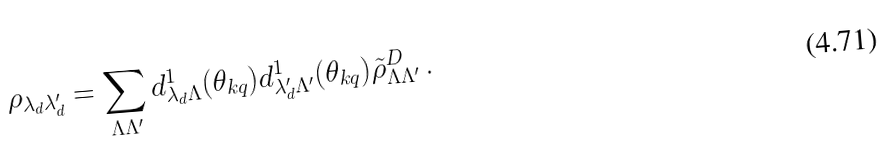<formula> <loc_0><loc_0><loc_500><loc_500>\rho _ { \lambda _ { d } \lambda ^ { \prime } _ { d } } = \sum _ { \Lambda \Lambda ^ { \prime } } d ^ { 1 } _ { \lambda _ { d } \Lambda } ( \theta _ { k q } ) d ^ { 1 } _ { \lambda ^ { \prime } _ { d } \Lambda ^ { \prime } } ( \theta _ { k q } ) \tilde { \rho } ^ { D } _ { \Lambda \Lambda ^ { \prime } } \, .</formula> 